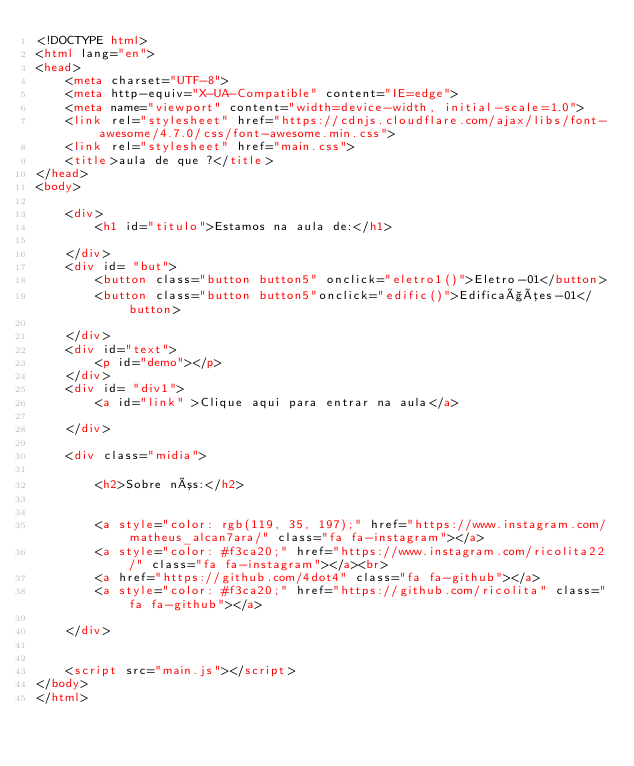Convert code to text. <code><loc_0><loc_0><loc_500><loc_500><_HTML_><!DOCTYPE html>
<html lang="en">
<head>
    <meta charset="UTF-8">
    <meta http-equiv="X-UA-Compatible" content="IE=edge">
    <meta name="viewport" content="width=device-width, initial-scale=1.0">
    <link rel="stylesheet" href="https://cdnjs.cloudflare.com/ajax/libs/font-awesome/4.7.0/css/font-awesome.min.css">
    <link rel="stylesheet" href="main.css">
    <title>aula de que ?</title>
</head>
<body>
   
    <div>
        <h1 id="titulo">Estamos na aula de:</h1>
        
    </div>
    <div id= "but">
        <button class="button button5" onclick="eletro1()">Eletro-01</button>
        <button class="button button5"onclick="edific()">Edificações-01</button>

    </div>
    <div id="text">
        <p id="demo"></p>
    </div>
    <div id= "div1">
        <a id="link" >Clique aqui para entrar na aula</a>
        
    </div> 
     
    <div class="midia">
        
        <h2>Sobre nós:</h2>
        

        <a style="color: rgb(119, 35, 197);" href="https://www.instagram.com/matheus_alcan7ara/" class="fa fa-instagram"></a>
        <a style="color: #f3ca20;" href="https://www.instagram.com/ricolita22/" class="fa fa-instagram"></a><br>
        <a href="https://github.com/4dot4" class="fa fa-github"></a>
        <a style="color: #f3ca20;" href="https://github.com/ricolita" class="fa fa-github"></a>
        
    </div>
     

    <script src="main.js"></script>
</body>
</html>
</code> 